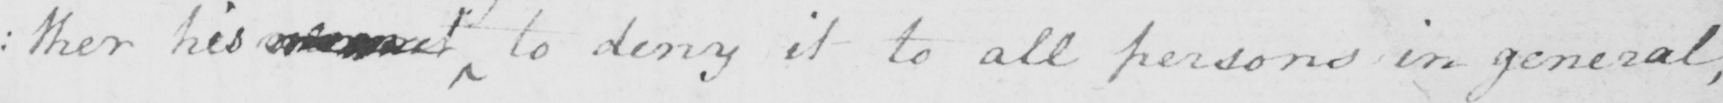Please transcribe the handwritten text in this image. : ther his   <gap/>   to deny it to all persons in general , 